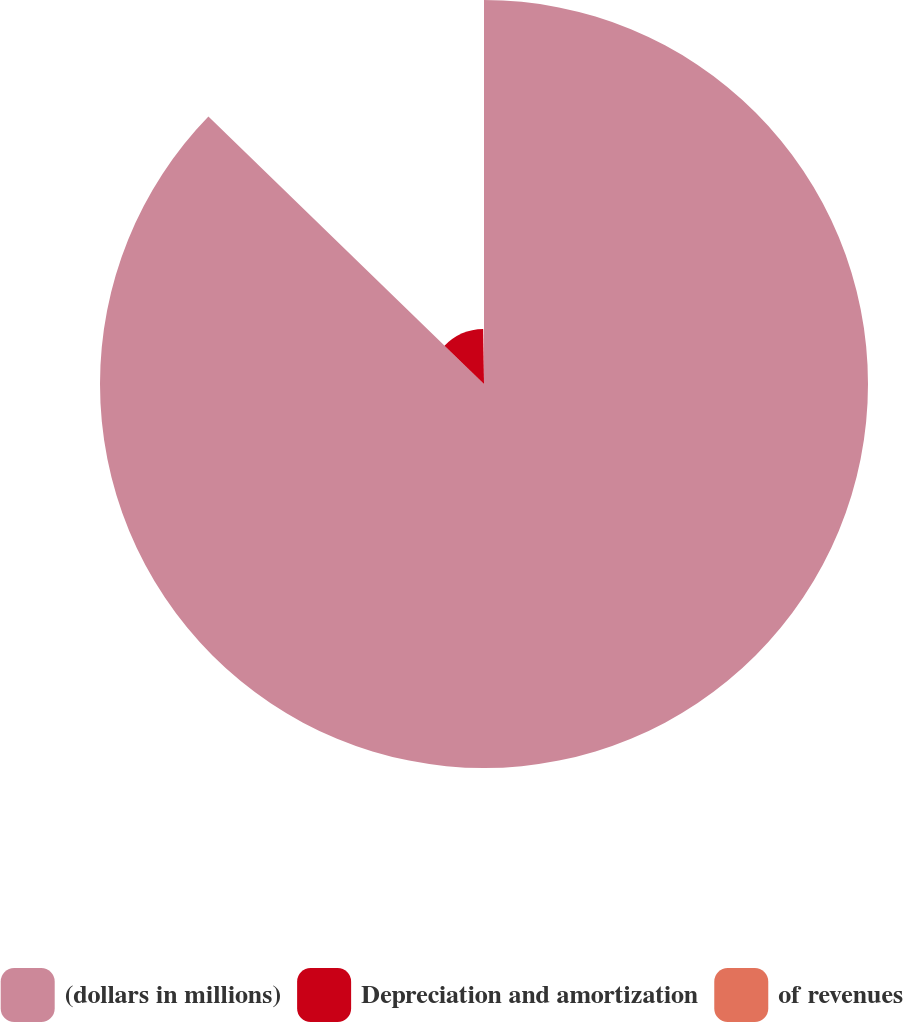<chart> <loc_0><loc_0><loc_500><loc_500><pie_chart><fcel>(dollars in millions)<fcel>Depreciation and amortization<fcel>of revenues<nl><fcel>87.26%<fcel>12.51%<fcel>0.23%<nl></chart> 